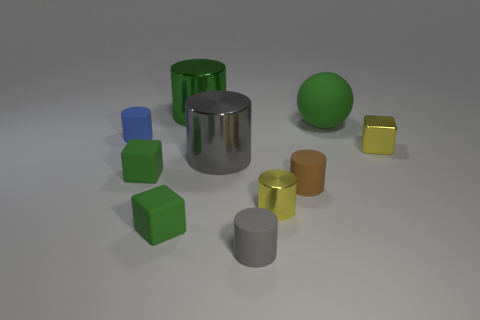Subtract all tiny yellow cylinders. How many cylinders are left? 5 Subtract 1 blocks. How many blocks are left? 2 Subtract all gray cylinders. How many cylinders are left? 4 Subtract all purple cylinders. Subtract all brown balls. How many cylinders are left? 6 Subtract all cylinders. How many objects are left? 4 Add 3 tiny cyan matte things. How many tiny cyan matte things exist? 3 Subtract 0 blue spheres. How many objects are left? 10 Subtract all tiny shiny cubes. Subtract all rubber spheres. How many objects are left? 8 Add 5 yellow metal cylinders. How many yellow metal cylinders are left? 6 